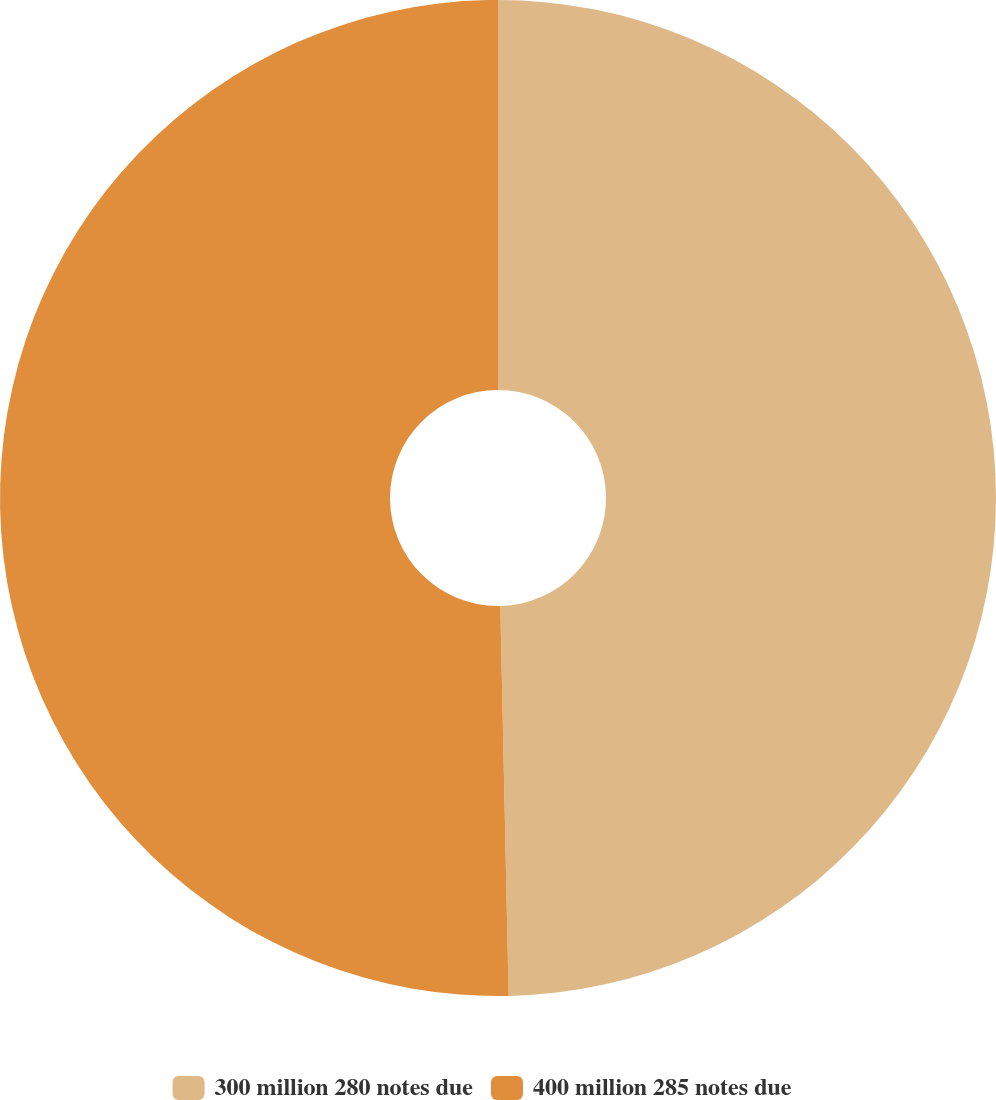Convert chart. <chart><loc_0><loc_0><loc_500><loc_500><pie_chart><fcel>300 million 280 notes due<fcel>400 million 285 notes due<nl><fcel>49.66%<fcel>50.34%<nl></chart> 